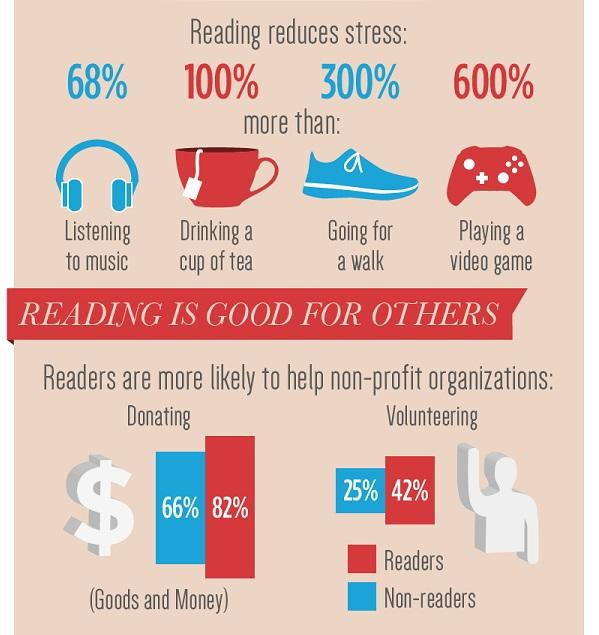Indicate a few pertinent items in this graphic. According to the given percentage, a significant majority of readers are more likely to donate goods and money to non-profit organizations. According to a survey, a significant percentage of readers are more likely to volunteer in helping non-profit organizations. Specifically, 42% of readers expressed a willingness to volunteer. 